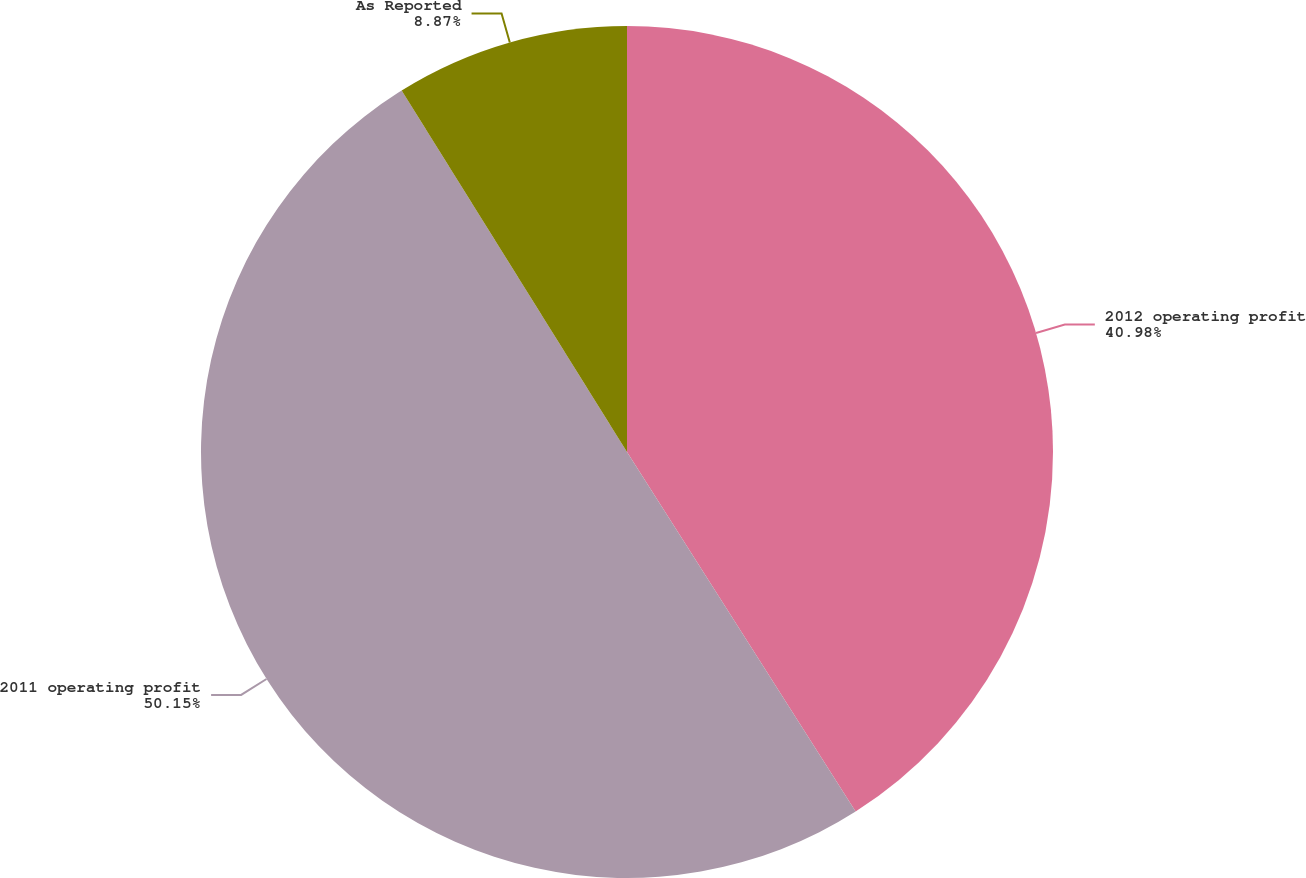<chart> <loc_0><loc_0><loc_500><loc_500><pie_chart><fcel>2012 operating profit<fcel>2011 operating profit<fcel>As Reported<nl><fcel>40.98%<fcel>50.14%<fcel>8.87%<nl></chart> 